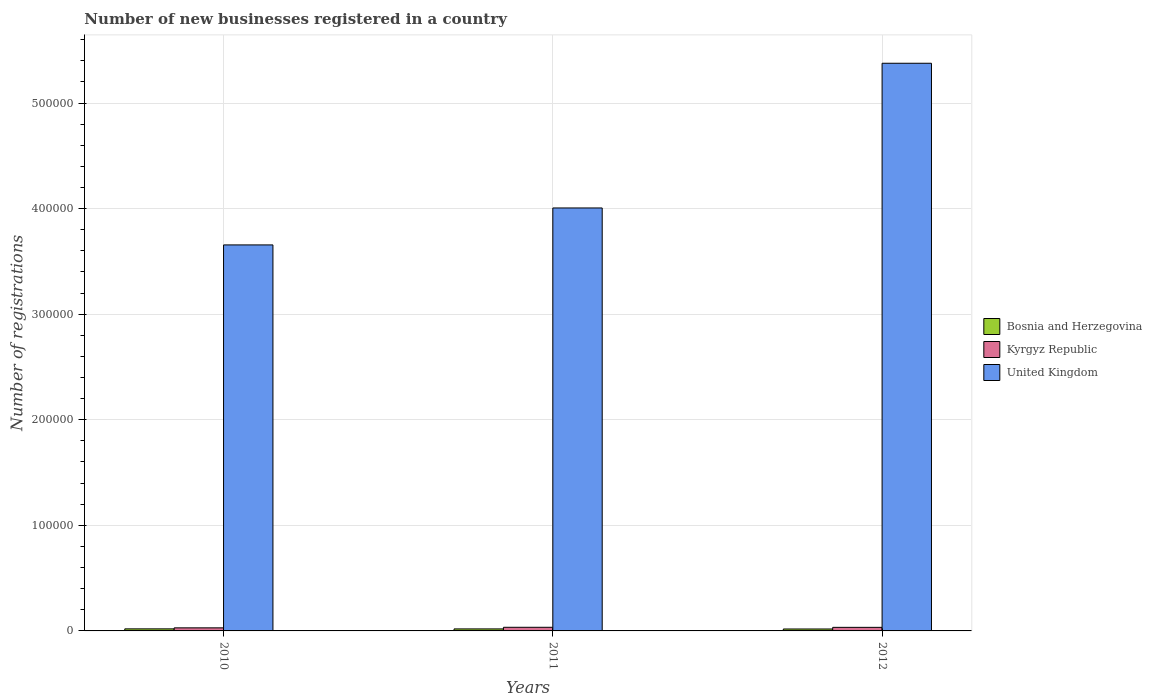How many groups of bars are there?
Ensure brevity in your answer.  3. How many bars are there on the 2nd tick from the left?
Give a very brief answer. 3. What is the label of the 3rd group of bars from the left?
Give a very brief answer. 2012. What is the number of new businesses registered in Kyrgyz Republic in 2011?
Provide a succinct answer. 3433. Across all years, what is the maximum number of new businesses registered in United Kingdom?
Keep it short and to the point. 5.38e+05. Across all years, what is the minimum number of new businesses registered in United Kingdom?
Your response must be concise. 3.66e+05. What is the total number of new businesses registered in United Kingdom in the graph?
Give a very brief answer. 1.30e+06. What is the difference between the number of new businesses registered in Kyrgyz Republic in 2011 and that in 2012?
Offer a very short reply. 54. What is the difference between the number of new businesses registered in United Kingdom in 2010 and the number of new businesses registered in Kyrgyz Republic in 2012?
Offer a very short reply. 3.62e+05. What is the average number of new businesses registered in Bosnia and Herzegovina per year?
Your answer should be compact. 1888. In the year 2011, what is the difference between the number of new businesses registered in United Kingdom and number of new businesses registered in Kyrgyz Republic?
Your answer should be very brief. 3.97e+05. What is the ratio of the number of new businesses registered in Bosnia and Herzegovina in 2011 to that in 2012?
Your answer should be very brief. 1.04. What is the difference between the highest and the second highest number of new businesses registered in Kyrgyz Republic?
Give a very brief answer. 54. What is the difference between the highest and the lowest number of new businesses registered in Kyrgyz Republic?
Make the answer very short. 528. What does the 1st bar from the left in 2011 represents?
Provide a succinct answer. Bosnia and Herzegovina. Is it the case that in every year, the sum of the number of new businesses registered in Kyrgyz Republic and number of new businesses registered in Bosnia and Herzegovina is greater than the number of new businesses registered in United Kingdom?
Give a very brief answer. No. How many bars are there?
Offer a very short reply. 9. How many years are there in the graph?
Your answer should be compact. 3. What is the difference between two consecutive major ticks on the Y-axis?
Offer a terse response. 1.00e+05. Where does the legend appear in the graph?
Your answer should be very brief. Center right. How many legend labels are there?
Your answer should be compact. 3. What is the title of the graph?
Provide a succinct answer. Number of new businesses registered in a country. What is the label or title of the Y-axis?
Offer a terse response. Number of registrations. What is the Number of registrations of Bosnia and Herzegovina in 2010?
Give a very brief answer. 1939. What is the Number of registrations of Kyrgyz Republic in 2010?
Make the answer very short. 2905. What is the Number of registrations of United Kingdom in 2010?
Make the answer very short. 3.66e+05. What is the Number of registrations of Bosnia and Herzegovina in 2011?
Provide a succinct answer. 1897. What is the Number of registrations of Kyrgyz Republic in 2011?
Your response must be concise. 3433. What is the Number of registrations of United Kingdom in 2011?
Keep it short and to the point. 4.01e+05. What is the Number of registrations of Bosnia and Herzegovina in 2012?
Provide a short and direct response. 1828. What is the Number of registrations in Kyrgyz Republic in 2012?
Your response must be concise. 3379. What is the Number of registrations of United Kingdom in 2012?
Make the answer very short. 5.38e+05. Across all years, what is the maximum Number of registrations in Bosnia and Herzegovina?
Provide a succinct answer. 1939. Across all years, what is the maximum Number of registrations of Kyrgyz Republic?
Offer a very short reply. 3433. Across all years, what is the maximum Number of registrations of United Kingdom?
Keep it short and to the point. 5.38e+05. Across all years, what is the minimum Number of registrations in Bosnia and Herzegovina?
Give a very brief answer. 1828. Across all years, what is the minimum Number of registrations in Kyrgyz Republic?
Offer a very short reply. 2905. Across all years, what is the minimum Number of registrations in United Kingdom?
Offer a terse response. 3.66e+05. What is the total Number of registrations in Bosnia and Herzegovina in the graph?
Ensure brevity in your answer.  5664. What is the total Number of registrations of Kyrgyz Republic in the graph?
Give a very brief answer. 9717. What is the total Number of registrations in United Kingdom in the graph?
Your response must be concise. 1.30e+06. What is the difference between the Number of registrations in Kyrgyz Republic in 2010 and that in 2011?
Your answer should be very brief. -528. What is the difference between the Number of registrations in United Kingdom in 2010 and that in 2011?
Your answer should be compact. -3.50e+04. What is the difference between the Number of registrations in Bosnia and Herzegovina in 2010 and that in 2012?
Your response must be concise. 111. What is the difference between the Number of registrations of Kyrgyz Republic in 2010 and that in 2012?
Offer a very short reply. -474. What is the difference between the Number of registrations in United Kingdom in 2010 and that in 2012?
Offer a terse response. -1.72e+05. What is the difference between the Number of registrations in Bosnia and Herzegovina in 2011 and that in 2012?
Provide a succinct answer. 69. What is the difference between the Number of registrations of United Kingdom in 2011 and that in 2012?
Offer a very short reply. -1.37e+05. What is the difference between the Number of registrations in Bosnia and Herzegovina in 2010 and the Number of registrations in Kyrgyz Republic in 2011?
Your answer should be very brief. -1494. What is the difference between the Number of registrations in Bosnia and Herzegovina in 2010 and the Number of registrations in United Kingdom in 2011?
Offer a very short reply. -3.99e+05. What is the difference between the Number of registrations in Kyrgyz Republic in 2010 and the Number of registrations in United Kingdom in 2011?
Your answer should be very brief. -3.98e+05. What is the difference between the Number of registrations of Bosnia and Herzegovina in 2010 and the Number of registrations of Kyrgyz Republic in 2012?
Give a very brief answer. -1440. What is the difference between the Number of registrations in Bosnia and Herzegovina in 2010 and the Number of registrations in United Kingdom in 2012?
Make the answer very short. -5.36e+05. What is the difference between the Number of registrations in Kyrgyz Republic in 2010 and the Number of registrations in United Kingdom in 2012?
Give a very brief answer. -5.35e+05. What is the difference between the Number of registrations in Bosnia and Herzegovina in 2011 and the Number of registrations in Kyrgyz Republic in 2012?
Offer a terse response. -1482. What is the difference between the Number of registrations of Bosnia and Herzegovina in 2011 and the Number of registrations of United Kingdom in 2012?
Provide a succinct answer. -5.36e+05. What is the difference between the Number of registrations in Kyrgyz Republic in 2011 and the Number of registrations in United Kingdom in 2012?
Provide a succinct answer. -5.34e+05. What is the average Number of registrations in Bosnia and Herzegovina per year?
Provide a short and direct response. 1888. What is the average Number of registrations in Kyrgyz Republic per year?
Make the answer very short. 3239. What is the average Number of registrations in United Kingdom per year?
Give a very brief answer. 4.35e+05. In the year 2010, what is the difference between the Number of registrations in Bosnia and Herzegovina and Number of registrations in Kyrgyz Republic?
Give a very brief answer. -966. In the year 2010, what is the difference between the Number of registrations in Bosnia and Herzegovina and Number of registrations in United Kingdom?
Your answer should be compact. -3.64e+05. In the year 2010, what is the difference between the Number of registrations in Kyrgyz Republic and Number of registrations in United Kingdom?
Offer a terse response. -3.63e+05. In the year 2011, what is the difference between the Number of registrations in Bosnia and Herzegovina and Number of registrations in Kyrgyz Republic?
Your response must be concise. -1536. In the year 2011, what is the difference between the Number of registrations in Bosnia and Herzegovina and Number of registrations in United Kingdom?
Your answer should be very brief. -3.99e+05. In the year 2011, what is the difference between the Number of registrations of Kyrgyz Republic and Number of registrations of United Kingdom?
Give a very brief answer. -3.97e+05. In the year 2012, what is the difference between the Number of registrations of Bosnia and Herzegovina and Number of registrations of Kyrgyz Republic?
Your answer should be very brief. -1551. In the year 2012, what is the difference between the Number of registrations of Bosnia and Herzegovina and Number of registrations of United Kingdom?
Provide a short and direct response. -5.36e+05. In the year 2012, what is the difference between the Number of registrations in Kyrgyz Republic and Number of registrations in United Kingdom?
Provide a short and direct response. -5.34e+05. What is the ratio of the Number of registrations in Bosnia and Herzegovina in 2010 to that in 2011?
Your answer should be very brief. 1.02. What is the ratio of the Number of registrations in Kyrgyz Republic in 2010 to that in 2011?
Your answer should be compact. 0.85. What is the ratio of the Number of registrations in United Kingdom in 2010 to that in 2011?
Provide a succinct answer. 0.91. What is the ratio of the Number of registrations in Bosnia and Herzegovina in 2010 to that in 2012?
Your answer should be very brief. 1.06. What is the ratio of the Number of registrations of Kyrgyz Republic in 2010 to that in 2012?
Your answer should be compact. 0.86. What is the ratio of the Number of registrations of United Kingdom in 2010 to that in 2012?
Your answer should be very brief. 0.68. What is the ratio of the Number of registrations of Bosnia and Herzegovina in 2011 to that in 2012?
Ensure brevity in your answer.  1.04. What is the ratio of the Number of registrations in United Kingdom in 2011 to that in 2012?
Offer a terse response. 0.75. What is the difference between the highest and the second highest Number of registrations of Bosnia and Herzegovina?
Your response must be concise. 42. What is the difference between the highest and the second highest Number of registrations of United Kingdom?
Your answer should be compact. 1.37e+05. What is the difference between the highest and the lowest Number of registrations of Bosnia and Herzegovina?
Ensure brevity in your answer.  111. What is the difference between the highest and the lowest Number of registrations of Kyrgyz Republic?
Provide a succinct answer. 528. What is the difference between the highest and the lowest Number of registrations of United Kingdom?
Your response must be concise. 1.72e+05. 